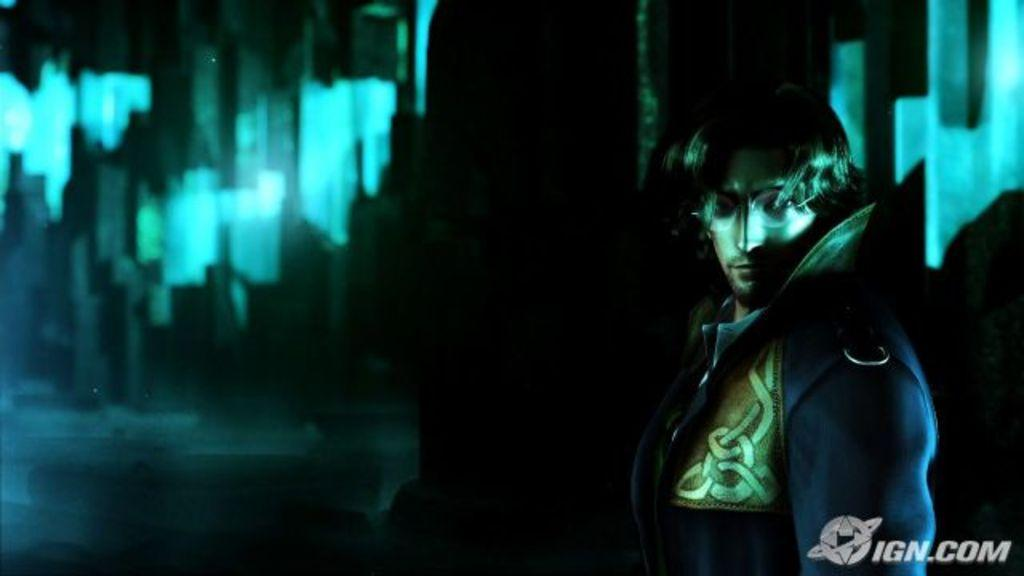Who is present in the image? There is a man in the image. What accessory is the man wearing? The man is wearing glasses. Where can text be found in the image? The text is located in the bottom right side of the image. What type of stick can be seen in the man's hand in the image? There is no stick present in the man's hand or anywhere in the image. 